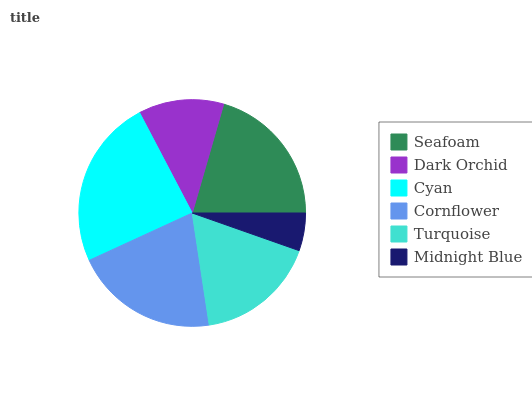Is Midnight Blue the minimum?
Answer yes or no. Yes. Is Cyan the maximum?
Answer yes or no. Yes. Is Dark Orchid the minimum?
Answer yes or no. No. Is Dark Orchid the maximum?
Answer yes or no. No. Is Seafoam greater than Dark Orchid?
Answer yes or no. Yes. Is Dark Orchid less than Seafoam?
Answer yes or no. Yes. Is Dark Orchid greater than Seafoam?
Answer yes or no. No. Is Seafoam less than Dark Orchid?
Answer yes or no. No. Is Seafoam the high median?
Answer yes or no. Yes. Is Turquoise the low median?
Answer yes or no. Yes. Is Dark Orchid the high median?
Answer yes or no. No. Is Midnight Blue the low median?
Answer yes or no. No. 